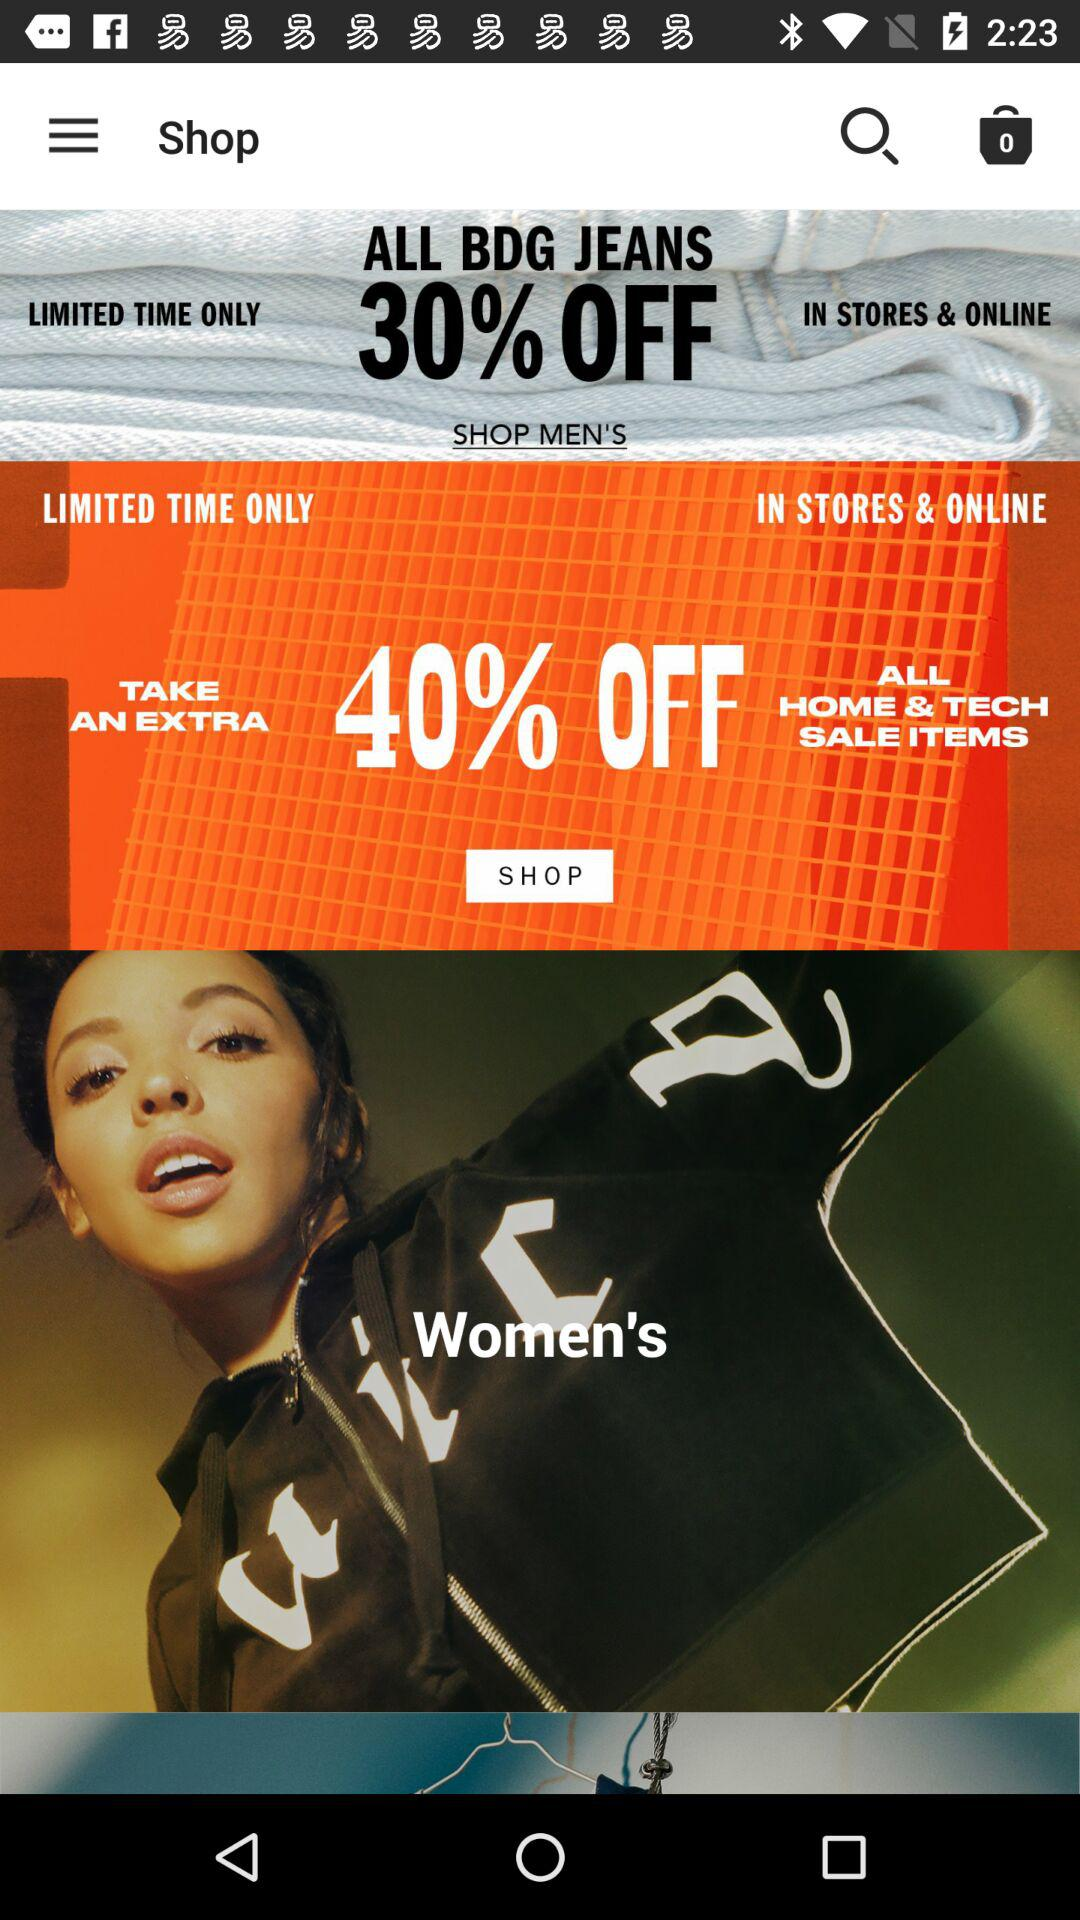How much discount is available on "BDG" Jeans? The discount available is 30%. 